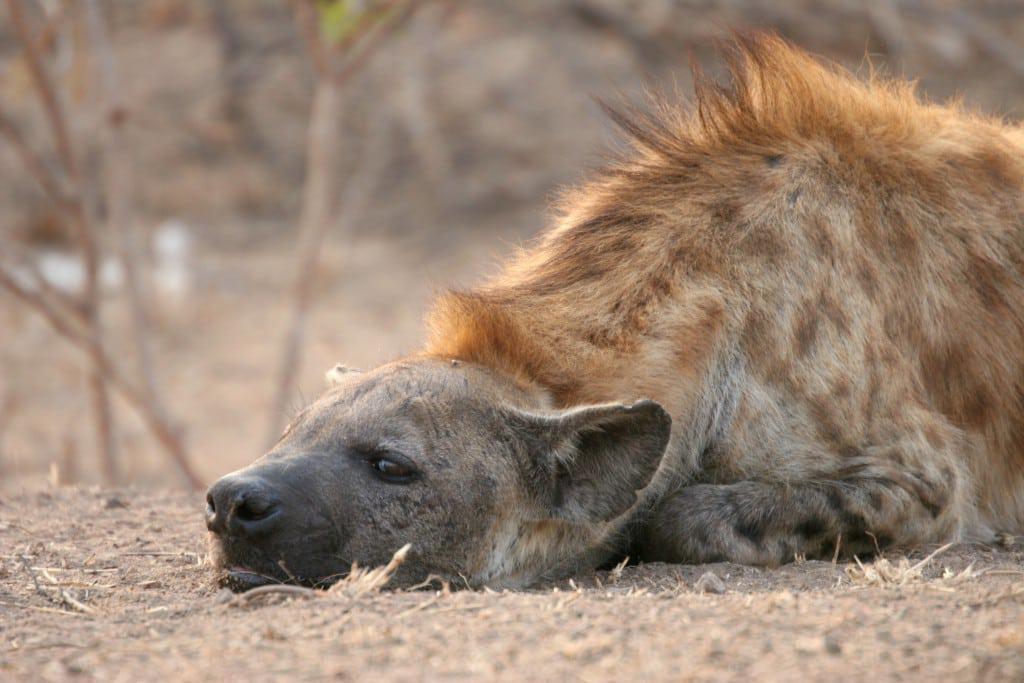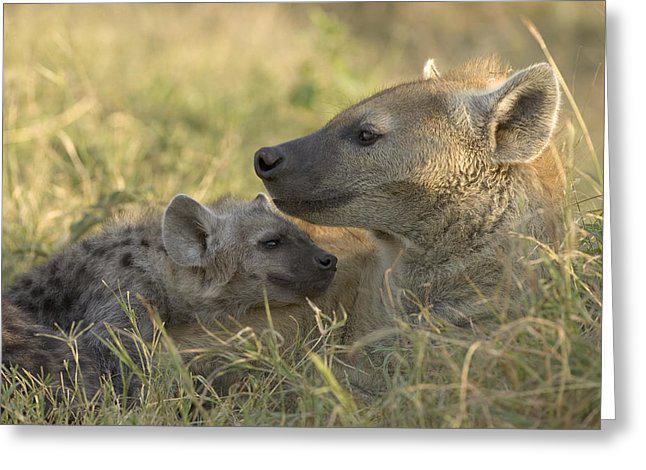The first image is the image on the left, the second image is the image on the right. Analyze the images presented: Is the assertion "The animal in one of the images has its head laying directly on the ground." valid? Answer yes or no. Yes. The first image is the image on the left, the second image is the image on the right. Examine the images to the left and right. Is the description "The left image features one adult hyena lying flat on its belly, and the right image includes an adult hyena reclining in some position." accurate? Answer yes or no. Yes. 